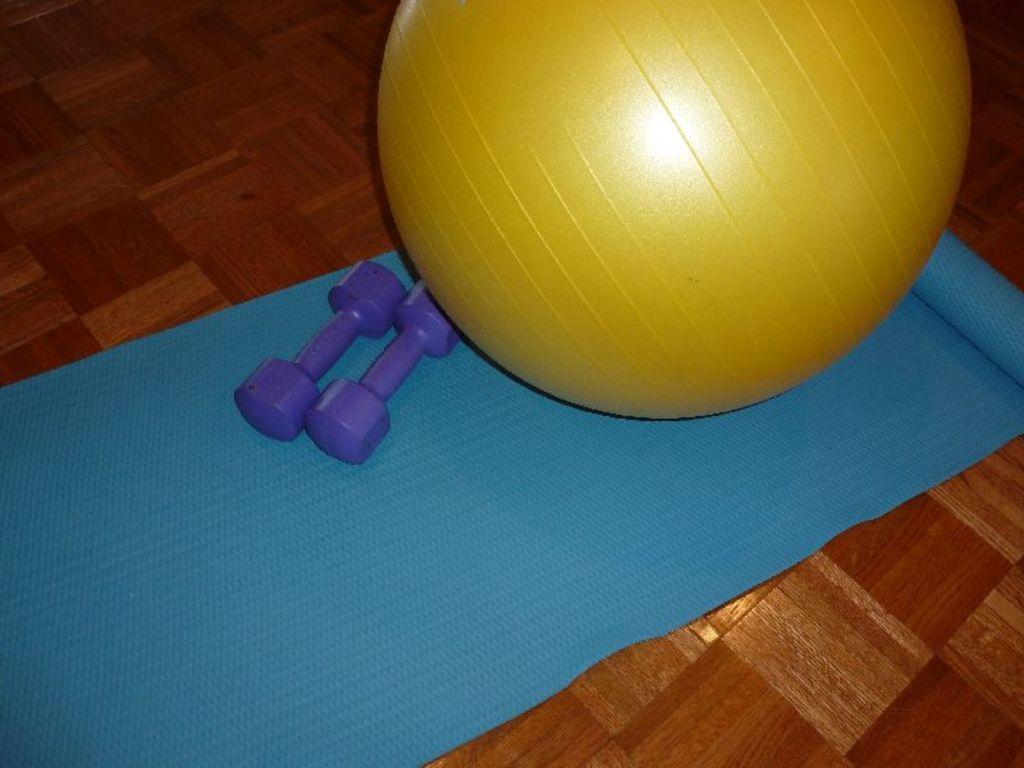Please provide a concise description of this image. In this image we can see an exercise mat on a floor. Also there is an exercise ball. Near to that there are dumbbells. 